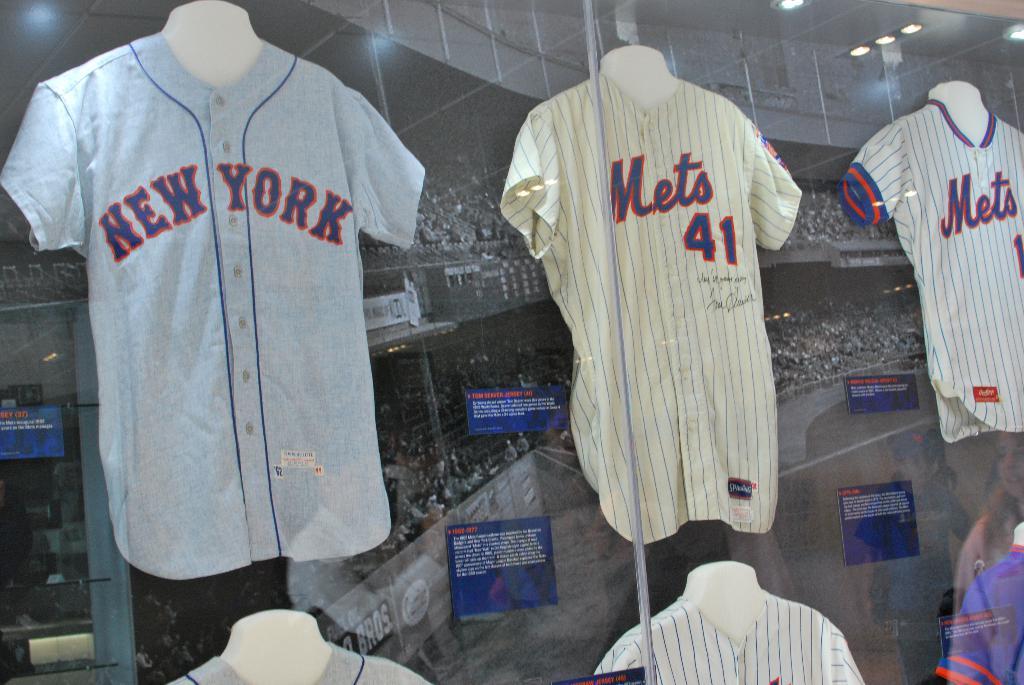What does the first shirt say?
Give a very brief answer. New york. 